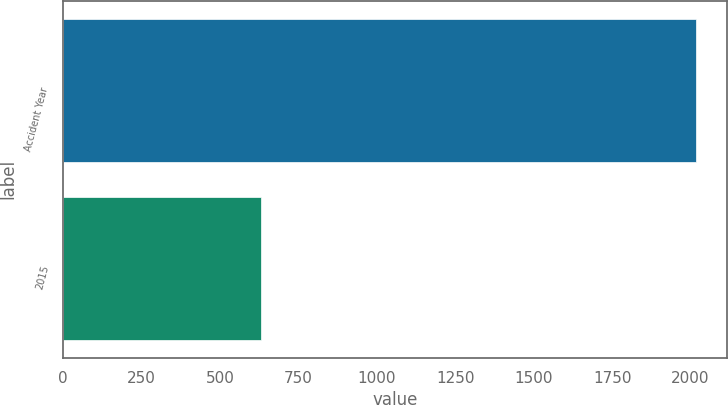Convert chart to OTSL. <chart><loc_0><loc_0><loc_500><loc_500><bar_chart><fcel>Accident Year<fcel>2015<nl><fcel>2016<fcel>630<nl></chart> 